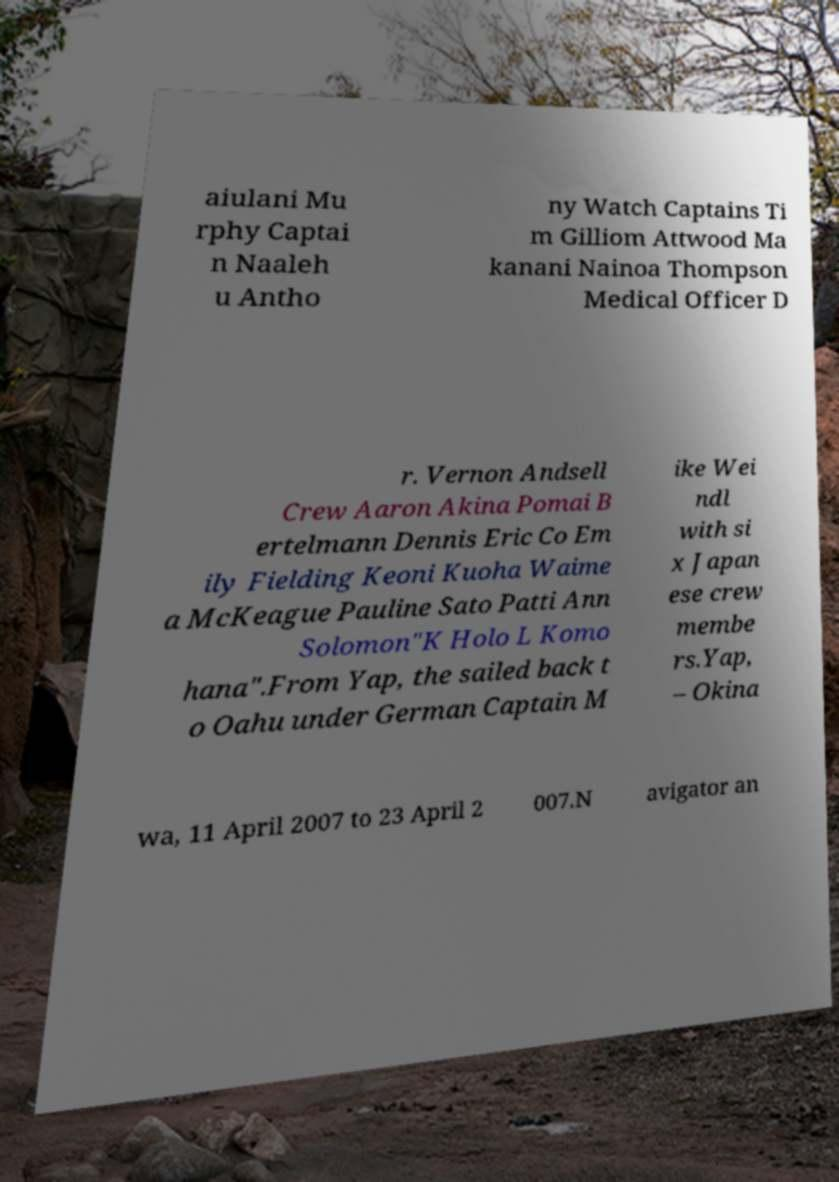Can you read and provide the text displayed in the image?This photo seems to have some interesting text. Can you extract and type it out for me? aiulani Mu rphy Captai n Naaleh u Antho ny Watch Captains Ti m Gilliom Attwood Ma kanani Nainoa Thompson Medical Officer D r. Vernon Andsell Crew Aaron Akina Pomai B ertelmann Dennis Eric Co Em ily Fielding Keoni Kuoha Waime a McKeague Pauline Sato Patti Ann Solomon"K Holo L Komo hana".From Yap, the sailed back t o Oahu under German Captain M ike Wei ndl with si x Japan ese crew membe rs.Yap, – Okina wa, 11 April 2007 to 23 April 2 007.N avigator an 